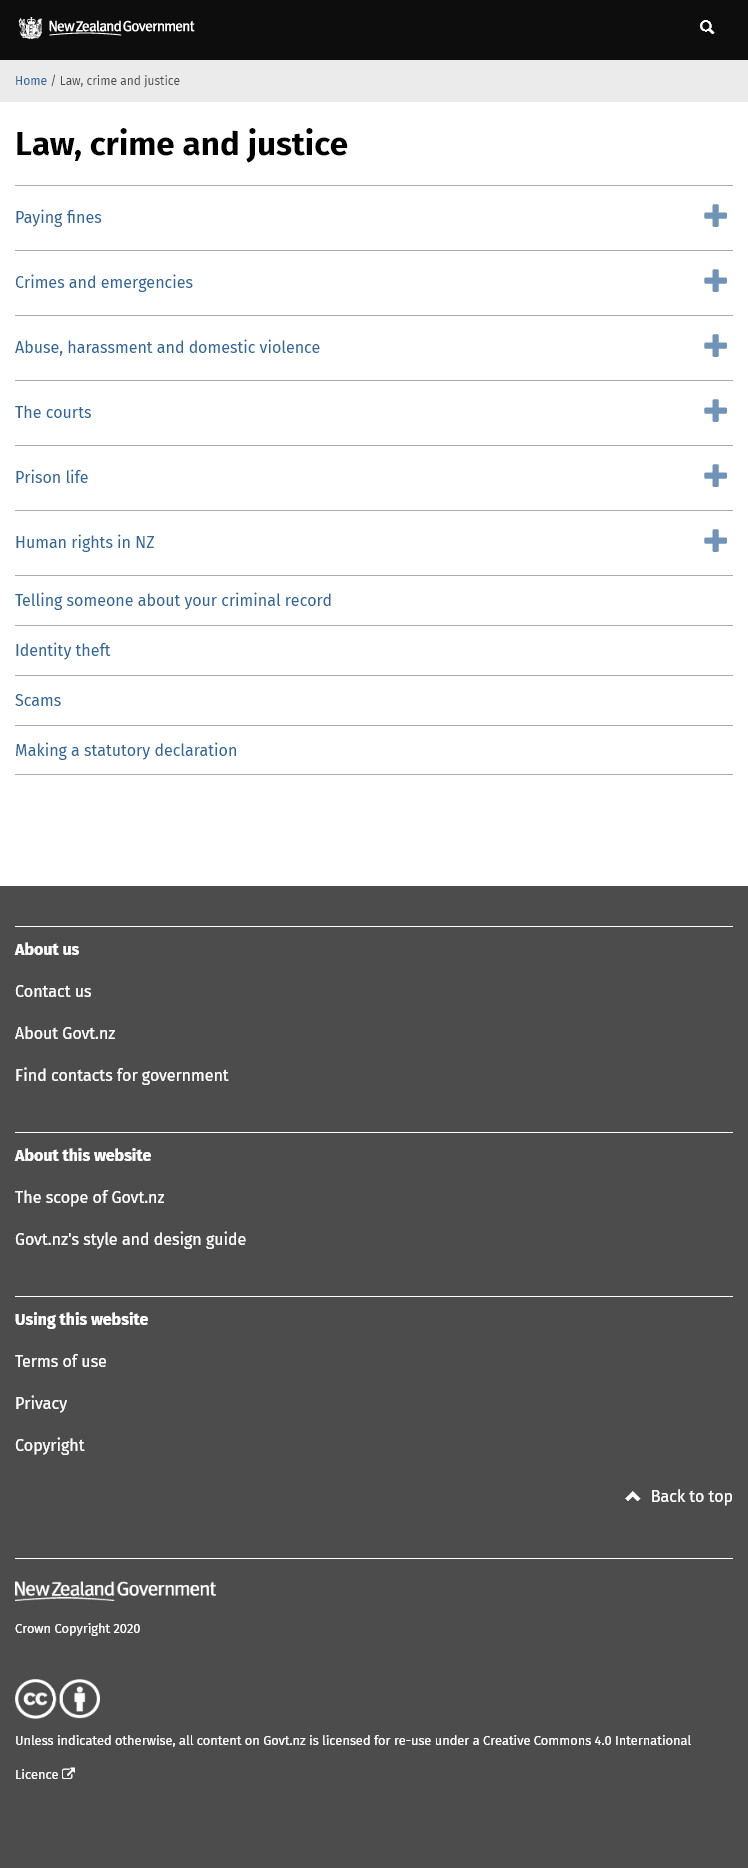Mention a couple of crucial points in this snapshot. Paying fines for Law, crime and justice is accomplished by clicking on the option 'Paying fines'. I am a victim of identity theft, and I desire to obtain additional information about this matter. Therefore, I request that you provide me with information on identity theft by clicking on the link labeled 'Identity Theft.' The user can contact the courts by clicking the courts' button. 